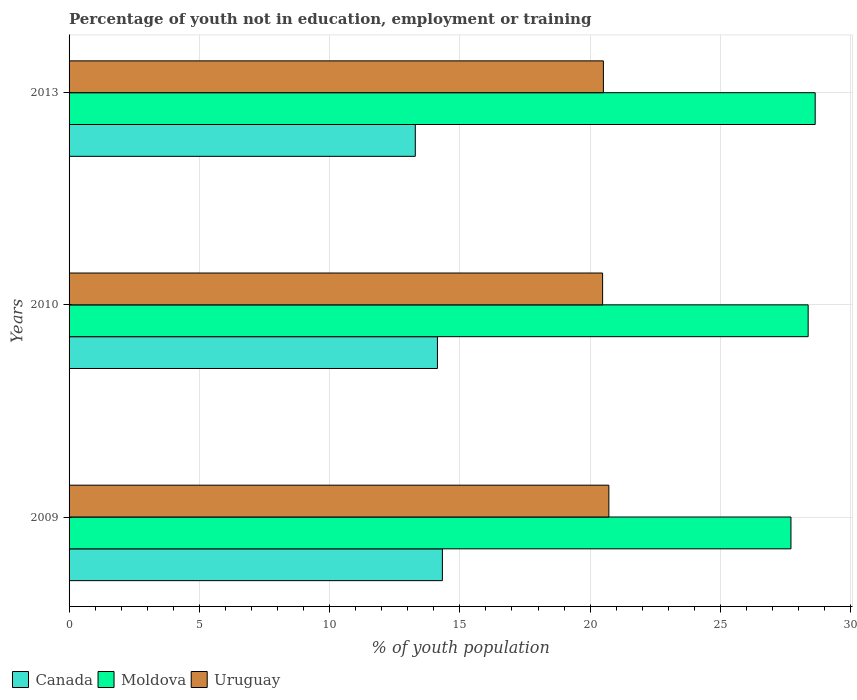How many different coloured bars are there?
Offer a very short reply. 3. Are the number of bars per tick equal to the number of legend labels?
Make the answer very short. Yes. How many bars are there on the 1st tick from the top?
Your answer should be compact. 3. How many bars are there on the 2nd tick from the bottom?
Make the answer very short. 3. What is the label of the 3rd group of bars from the top?
Your answer should be very brief. 2009. In how many cases, is the number of bars for a given year not equal to the number of legend labels?
Your answer should be very brief. 0. What is the percentage of unemployed youth population in in Moldova in 2013?
Give a very brief answer. 28.64. Across all years, what is the maximum percentage of unemployed youth population in in Canada?
Keep it short and to the point. 14.33. Across all years, what is the minimum percentage of unemployed youth population in in Canada?
Offer a very short reply. 13.29. In which year was the percentage of unemployed youth population in in Canada maximum?
Provide a short and direct response. 2009. What is the total percentage of unemployed youth population in in Uruguay in the graph?
Keep it short and to the point. 61.71. What is the difference between the percentage of unemployed youth population in in Canada in 2010 and that in 2013?
Your answer should be compact. 0.85. What is the difference between the percentage of unemployed youth population in in Uruguay in 2010 and the percentage of unemployed youth population in in Moldova in 2009?
Ensure brevity in your answer.  -7.23. What is the average percentage of unemployed youth population in in Canada per year?
Give a very brief answer. 13.92. In the year 2010, what is the difference between the percentage of unemployed youth population in in Uruguay and percentage of unemployed youth population in in Canada?
Make the answer very short. 6.34. What is the ratio of the percentage of unemployed youth population in in Canada in 2010 to that in 2013?
Provide a succinct answer. 1.06. Is the percentage of unemployed youth population in in Canada in 2009 less than that in 2013?
Your response must be concise. No. Is the difference between the percentage of unemployed youth population in in Uruguay in 2009 and 2010 greater than the difference between the percentage of unemployed youth population in in Canada in 2009 and 2010?
Your answer should be very brief. Yes. What is the difference between the highest and the second highest percentage of unemployed youth population in in Canada?
Keep it short and to the point. 0.19. What is the difference between the highest and the lowest percentage of unemployed youth population in in Canada?
Make the answer very short. 1.04. Is the sum of the percentage of unemployed youth population in in Uruguay in 2010 and 2013 greater than the maximum percentage of unemployed youth population in in Canada across all years?
Offer a terse response. Yes. What does the 3rd bar from the top in 2010 represents?
Provide a succinct answer. Canada. What does the 1st bar from the bottom in 2010 represents?
Your response must be concise. Canada. How many bars are there?
Make the answer very short. 9. What is the difference between two consecutive major ticks on the X-axis?
Give a very brief answer. 5. How are the legend labels stacked?
Offer a terse response. Horizontal. What is the title of the graph?
Your answer should be very brief. Percentage of youth not in education, employment or training. Does "Peru" appear as one of the legend labels in the graph?
Ensure brevity in your answer.  No. What is the label or title of the X-axis?
Make the answer very short. % of youth population. What is the % of youth population in Canada in 2009?
Make the answer very short. 14.33. What is the % of youth population of Moldova in 2009?
Make the answer very short. 27.71. What is the % of youth population of Uruguay in 2009?
Offer a terse response. 20.72. What is the % of youth population in Canada in 2010?
Provide a short and direct response. 14.14. What is the % of youth population in Moldova in 2010?
Your response must be concise. 28.37. What is the % of youth population in Uruguay in 2010?
Offer a very short reply. 20.48. What is the % of youth population in Canada in 2013?
Provide a succinct answer. 13.29. What is the % of youth population in Moldova in 2013?
Your answer should be compact. 28.64. What is the % of youth population of Uruguay in 2013?
Your answer should be very brief. 20.51. Across all years, what is the maximum % of youth population of Canada?
Offer a very short reply. 14.33. Across all years, what is the maximum % of youth population of Moldova?
Keep it short and to the point. 28.64. Across all years, what is the maximum % of youth population in Uruguay?
Ensure brevity in your answer.  20.72. Across all years, what is the minimum % of youth population in Canada?
Give a very brief answer. 13.29. Across all years, what is the minimum % of youth population of Moldova?
Give a very brief answer. 27.71. Across all years, what is the minimum % of youth population in Uruguay?
Your answer should be very brief. 20.48. What is the total % of youth population of Canada in the graph?
Offer a very short reply. 41.76. What is the total % of youth population of Moldova in the graph?
Offer a terse response. 84.72. What is the total % of youth population in Uruguay in the graph?
Your answer should be very brief. 61.71. What is the difference between the % of youth population of Canada in 2009 and that in 2010?
Offer a terse response. 0.19. What is the difference between the % of youth population of Moldova in 2009 and that in 2010?
Keep it short and to the point. -0.66. What is the difference between the % of youth population of Uruguay in 2009 and that in 2010?
Keep it short and to the point. 0.24. What is the difference between the % of youth population in Canada in 2009 and that in 2013?
Keep it short and to the point. 1.04. What is the difference between the % of youth population of Moldova in 2009 and that in 2013?
Offer a very short reply. -0.93. What is the difference between the % of youth population in Uruguay in 2009 and that in 2013?
Your answer should be compact. 0.21. What is the difference between the % of youth population of Moldova in 2010 and that in 2013?
Your response must be concise. -0.27. What is the difference between the % of youth population in Uruguay in 2010 and that in 2013?
Offer a very short reply. -0.03. What is the difference between the % of youth population of Canada in 2009 and the % of youth population of Moldova in 2010?
Give a very brief answer. -14.04. What is the difference between the % of youth population of Canada in 2009 and the % of youth population of Uruguay in 2010?
Keep it short and to the point. -6.15. What is the difference between the % of youth population in Moldova in 2009 and the % of youth population in Uruguay in 2010?
Ensure brevity in your answer.  7.23. What is the difference between the % of youth population of Canada in 2009 and the % of youth population of Moldova in 2013?
Give a very brief answer. -14.31. What is the difference between the % of youth population in Canada in 2009 and the % of youth population in Uruguay in 2013?
Offer a terse response. -6.18. What is the difference between the % of youth population of Moldova in 2009 and the % of youth population of Uruguay in 2013?
Provide a short and direct response. 7.2. What is the difference between the % of youth population in Canada in 2010 and the % of youth population in Uruguay in 2013?
Your answer should be very brief. -6.37. What is the difference between the % of youth population in Moldova in 2010 and the % of youth population in Uruguay in 2013?
Your answer should be compact. 7.86. What is the average % of youth population of Canada per year?
Make the answer very short. 13.92. What is the average % of youth population in Moldova per year?
Make the answer very short. 28.24. What is the average % of youth population in Uruguay per year?
Offer a terse response. 20.57. In the year 2009, what is the difference between the % of youth population in Canada and % of youth population in Moldova?
Your answer should be very brief. -13.38. In the year 2009, what is the difference between the % of youth population of Canada and % of youth population of Uruguay?
Keep it short and to the point. -6.39. In the year 2009, what is the difference between the % of youth population of Moldova and % of youth population of Uruguay?
Your answer should be compact. 6.99. In the year 2010, what is the difference between the % of youth population in Canada and % of youth population in Moldova?
Provide a short and direct response. -14.23. In the year 2010, what is the difference between the % of youth population of Canada and % of youth population of Uruguay?
Make the answer very short. -6.34. In the year 2010, what is the difference between the % of youth population in Moldova and % of youth population in Uruguay?
Provide a succinct answer. 7.89. In the year 2013, what is the difference between the % of youth population of Canada and % of youth population of Moldova?
Your response must be concise. -15.35. In the year 2013, what is the difference between the % of youth population of Canada and % of youth population of Uruguay?
Keep it short and to the point. -7.22. In the year 2013, what is the difference between the % of youth population of Moldova and % of youth population of Uruguay?
Your answer should be very brief. 8.13. What is the ratio of the % of youth population of Canada in 2009 to that in 2010?
Your answer should be compact. 1.01. What is the ratio of the % of youth population of Moldova in 2009 to that in 2010?
Your response must be concise. 0.98. What is the ratio of the % of youth population of Uruguay in 2009 to that in 2010?
Give a very brief answer. 1.01. What is the ratio of the % of youth population in Canada in 2009 to that in 2013?
Ensure brevity in your answer.  1.08. What is the ratio of the % of youth population of Moldova in 2009 to that in 2013?
Your answer should be compact. 0.97. What is the ratio of the % of youth population of Uruguay in 2009 to that in 2013?
Your response must be concise. 1.01. What is the ratio of the % of youth population in Canada in 2010 to that in 2013?
Your answer should be very brief. 1.06. What is the ratio of the % of youth population of Moldova in 2010 to that in 2013?
Ensure brevity in your answer.  0.99. What is the difference between the highest and the second highest % of youth population of Canada?
Your response must be concise. 0.19. What is the difference between the highest and the second highest % of youth population of Moldova?
Offer a terse response. 0.27. What is the difference between the highest and the second highest % of youth population of Uruguay?
Keep it short and to the point. 0.21. What is the difference between the highest and the lowest % of youth population in Uruguay?
Your response must be concise. 0.24. 